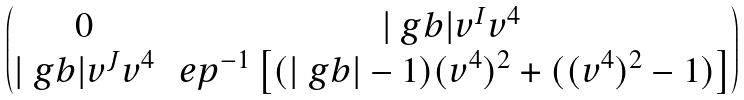Convert formula to latex. <formula><loc_0><loc_0><loc_500><loc_500>\begin{pmatrix} 0 & | \ g b | v ^ { I } v ^ { 4 } \\ | \ g b | v ^ { J } v ^ { 4 } & \ e p ^ { - 1 } \left [ ( | \ g b | - 1 ) ( v ^ { 4 } ) ^ { 2 } + ( ( v ^ { 4 } ) ^ { 2 } - 1 ) \right ] \end{pmatrix}</formula> 